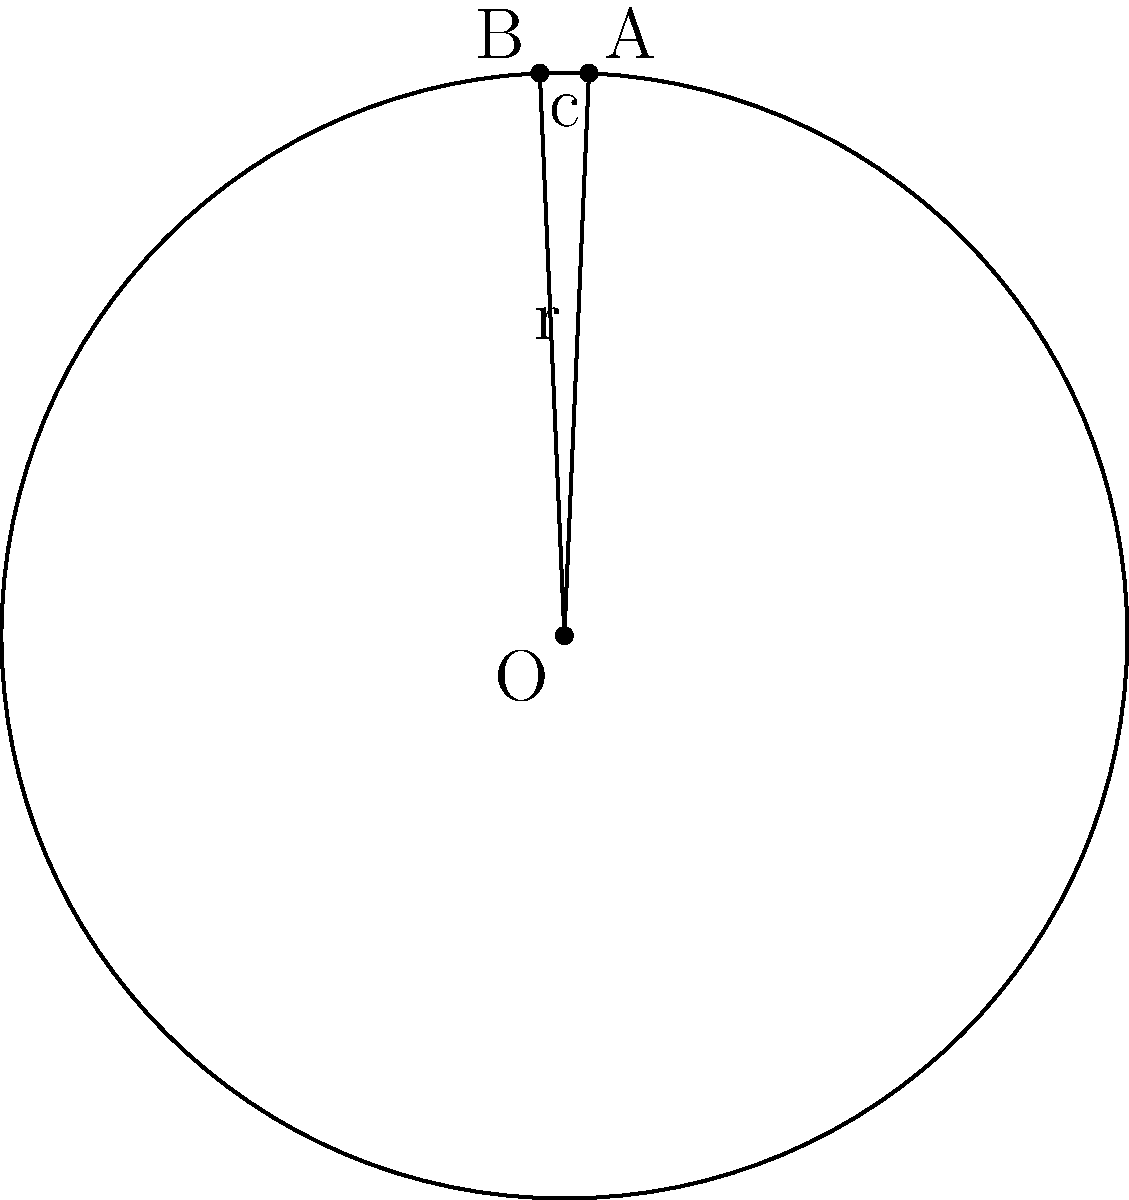In a circle with radius 10 cm, a chord of length 12 cm is drawn. Calculate the area of the smaller circular segment formed by this chord. Round your answer to the nearest square centimeter. Let's approach this step-by-step:

1) First, we need to find the central angle subtended by the chord. Let's call half of this angle θ.

2) We can use the formula: $\cos \theta = \frac{\text{radius}}{\text{half chord length}}$

   $\cos \theta = \frac{10}{6} = \frac{5}{3}$

3) Therefore, $\theta = \arccos(\frac{5}{3}) \approx 0.9273$ radians

4) The area of a circular segment is given by the formula:
   
   $A = r^2 \arccos(\frac{r-h}{r}) - (r-h)\sqrt{2rh-h^2}$

   where $r$ is the radius and $h$ is the height of the segment.

5) We don't know $h$ directly, but we can calculate it:
   
   $h = r - r\cos\theta = 10 - 10\cos(0.9273) \approx 3.97$ cm

6) Now we can plug everything into our area formula:

   $A = 10^2 \arccos(\frac{10-3.97}{10}) - (10-3.97)\sqrt{2(10)(3.97)-(3.97)^2}$

7) Calculating this:

   $A \approx 31.42$ cm²

8) Rounding to the nearest square centimeter:

   $A \approx 31$ cm²
Answer: 31 cm² 